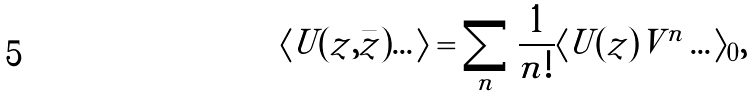<formula> <loc_0><loc_0><loc_500><loc_500>\langle U ( z , \bar { z } ) \dots \rangle = \sum _ { n } \frac { 1 } { n ! } \langle U ( z ) V ^ { n } \dots \rangle _ { 0 } ,</formula> 